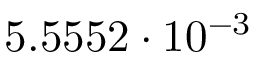<formula> <loc_0><loc_0><loc_500><loc_500>5 . 5 5 5 2 \cdot 1 0 ^ { - 3 }</formula> 